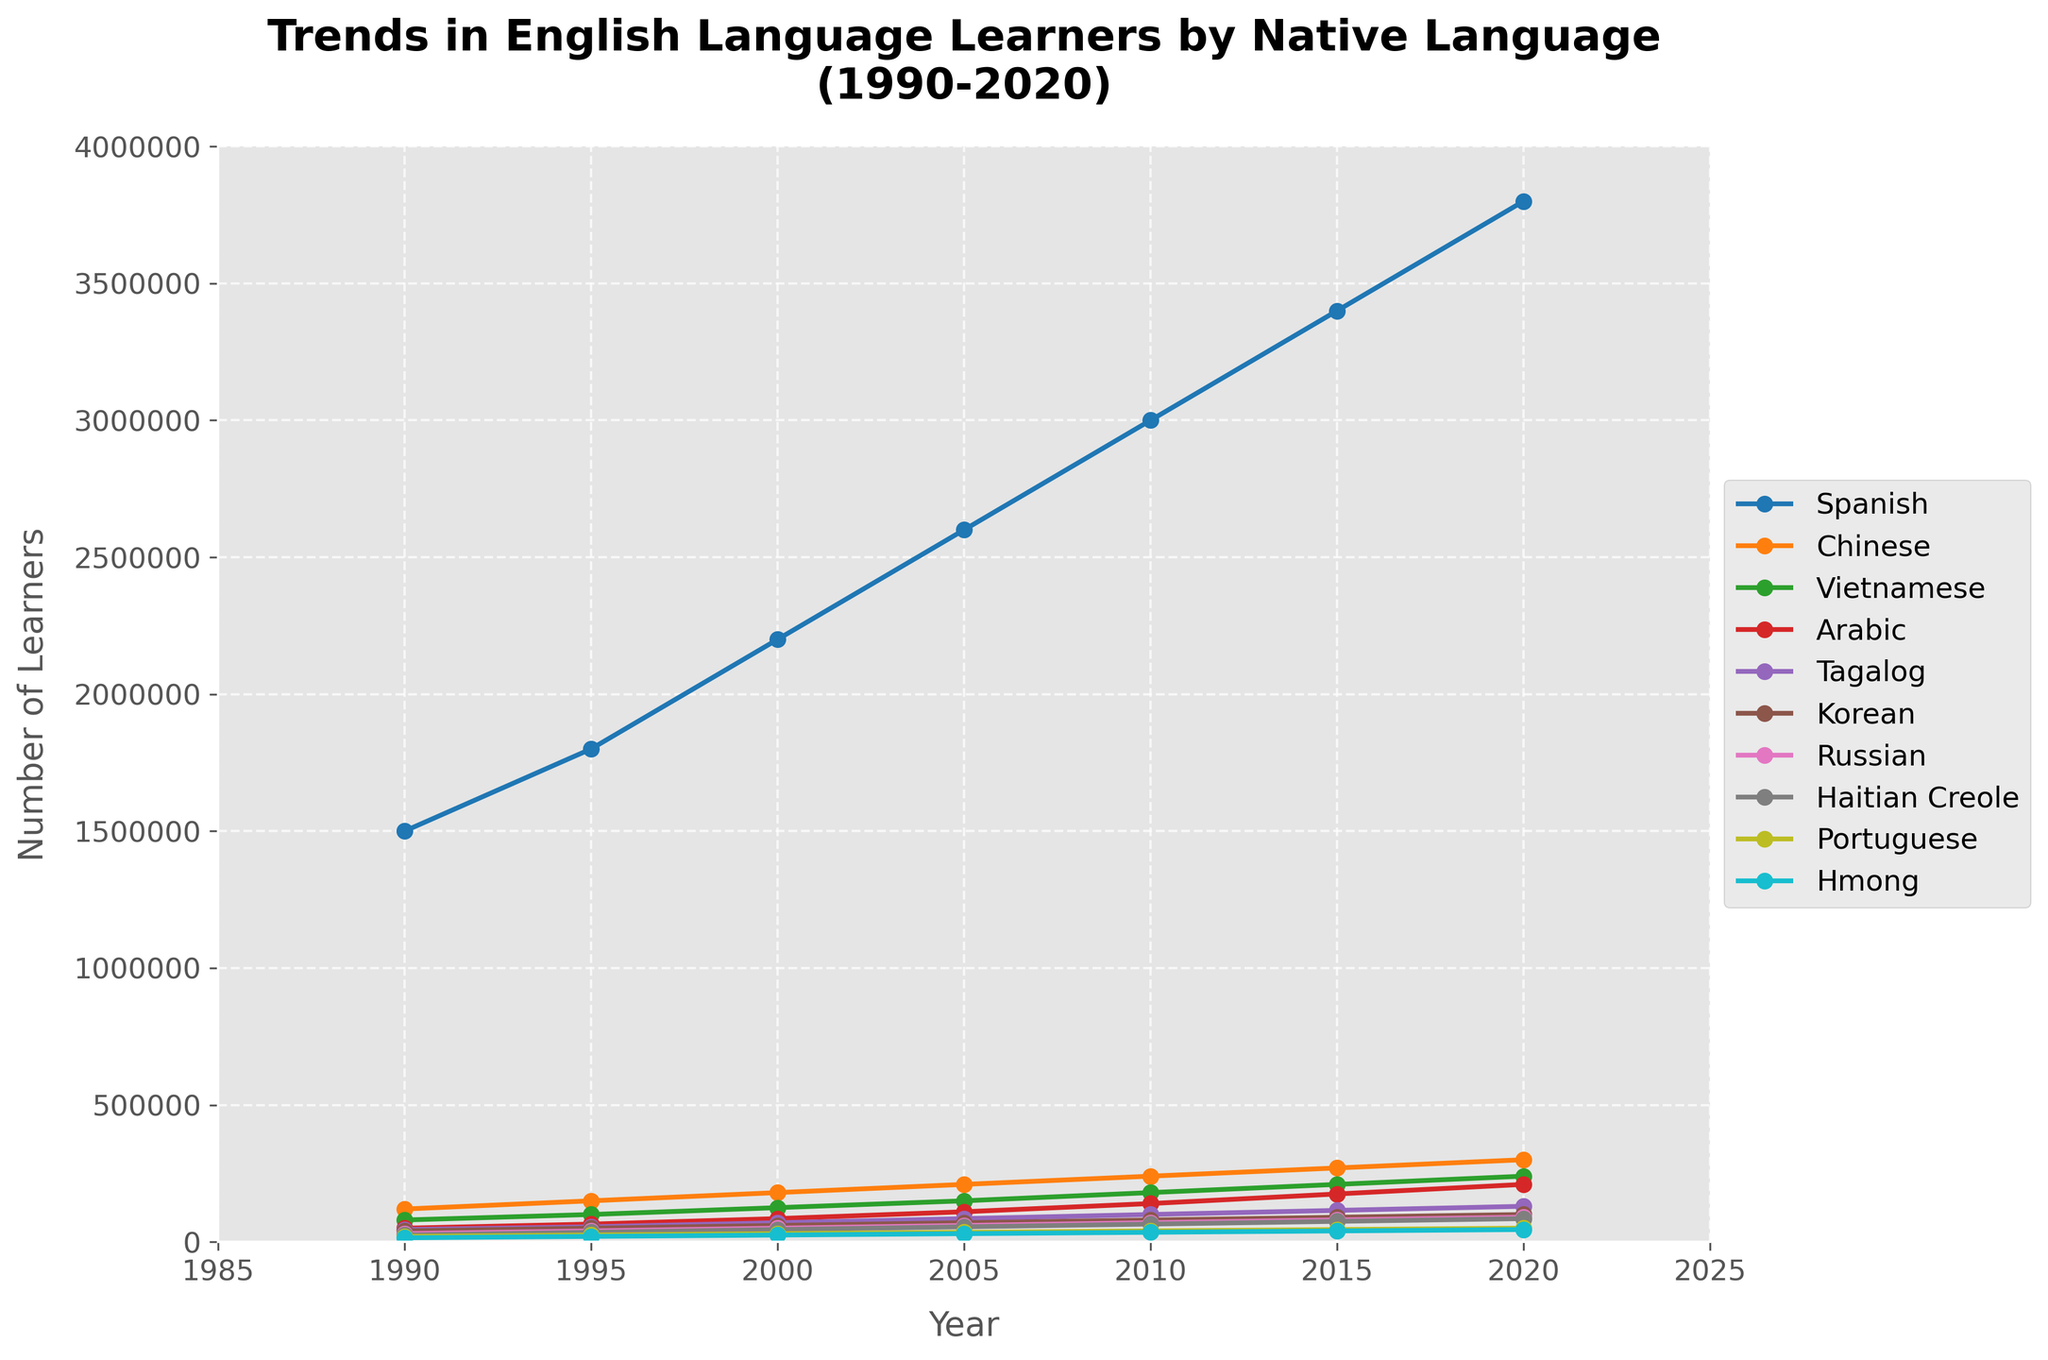Which language saw the largest increase in the number of learners between 1990 and 2020? To determine the language with the largest increase, subtract the number of learners in 1990 from the number in 2020 for each language. Spanish: 3800000 - 1500000 = 2300000; Chinese: 300000 - 120000 = 180000; Vietnamese: 240000 - 80000 = 160000; Arabic: 210000 - 50000 = 160000; Tagalog: 130000 - 45000 = 85000; Korean: 100000 - 40000 = 60000; Russian: 90000 - 30000 = 60000; Haitian Creole: 85000 - 25000 = 60000; Portuguese: 50000 - 20000 = 30000; Hmong: 45000 - 15000 = 30000. Spanish saw the largest increase of 2300000 learners.
Answer: Spanish Which two languages had a similar number of learners in 2020, and how many learners were there for each? From the plot, Korean and Russian had similar numbers of learners in 2020. Both were at approximately 100000 and 90000, respectively.
Answer: Korean: 100000, Russian: 90000 How much more did the number of Spanish learners increase compared to Chinese learners from 1990 to 2020? First, calculate the increase for both languages: Spanish: 3800000 - 1500000 = 2300000; Chinese: 300000 - 120000 = 180000. Then, subtract the increase of Chinese learners from the increase of Spanish learners: 2300000 - 180000 = 2120000.
Answer: 2120000 Among the ten languages, which language has shown the slowest growth over the 30-year period? Calculate the growth for each language from 1990 to 2020 and compare. Hmong grew from 15000 to 45000, a growth of 30000. This is the smallest increase among all the languages listed.
Answer: Hmong Which year did Vietnamese surpass Tagalog in the number of learners? By visually inspecting the plot, the two lines cross between 2000 and 2005. Further inspection shows that in 2005, Vietnamese surpassed Tagalog.
Answer: 2005 Between 1990 and 2020, did any language see a decrease in the number of learners? By observing the trends in the plot, none of the languages show a decrease over the years from 1990 to 2020. All trends are upward or steady.
Answer: No What is the approximate average number of learners for Arabic from 1990 to 2020? Sum the number of learners for Arabic in each year: 50000 + 65000 + 85000 + 110000 + 140000 + 175000 + 210000 = 835000. Divide by the number of years (7): 835000 / 7 ≈ 119285.7.
Answer: ≈ 119286 